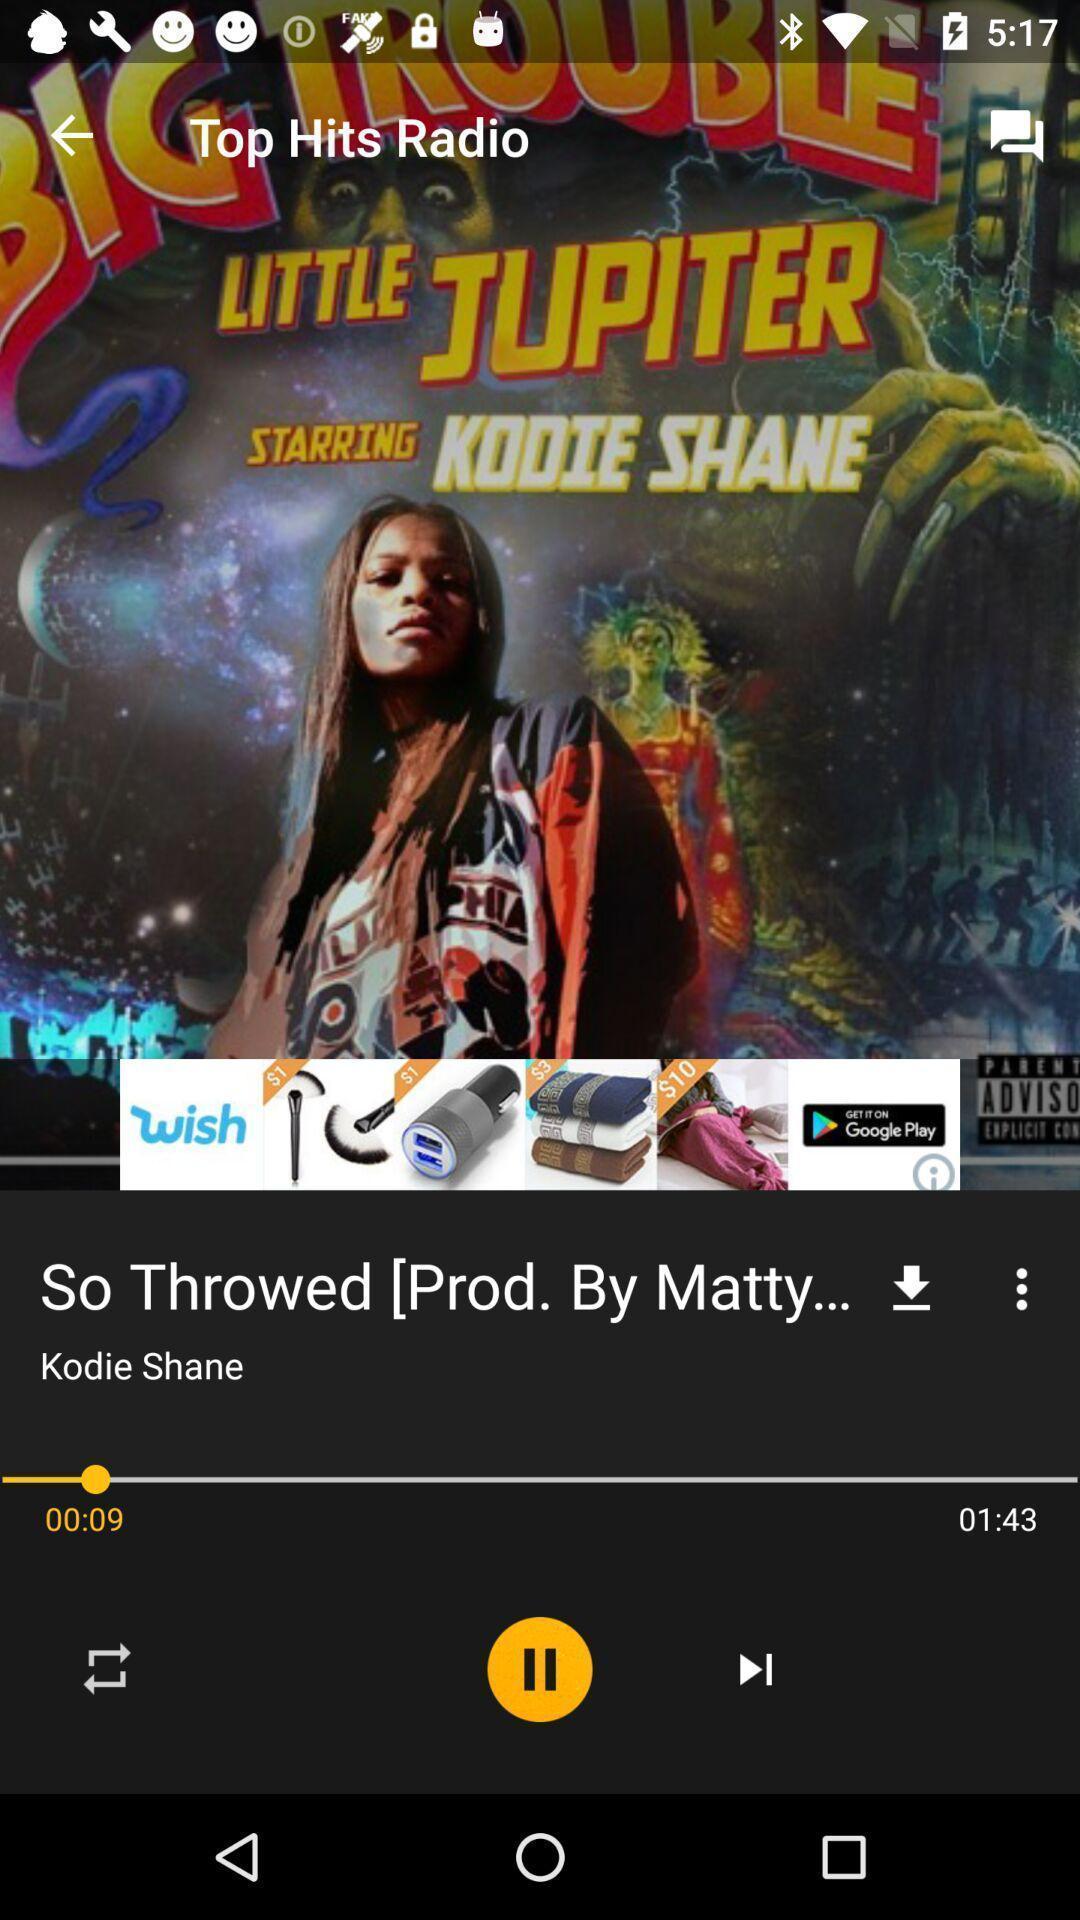Explain what's happening in this screen capture. Song page of a music app. 